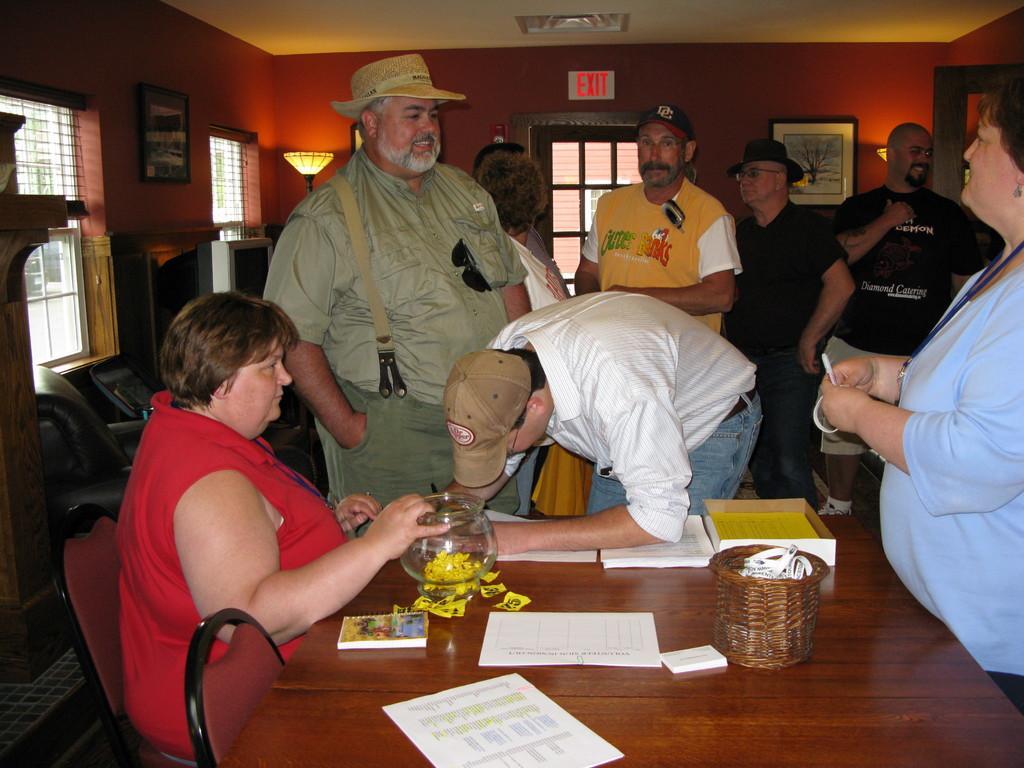Describe this image in one or two sentences. The picture is taken inside a room. There are few people inside the room. In the left side one lady wearing a red dress is sitting on chair. In front of her there is a table. On the table there are few papers, glass jar,basket,and books. In the right side a lady is standing wearing a blue top. In the left top there are windows,chairs,paint, tv. In the background there is a door, there painting and on the top there is an exit sign. 